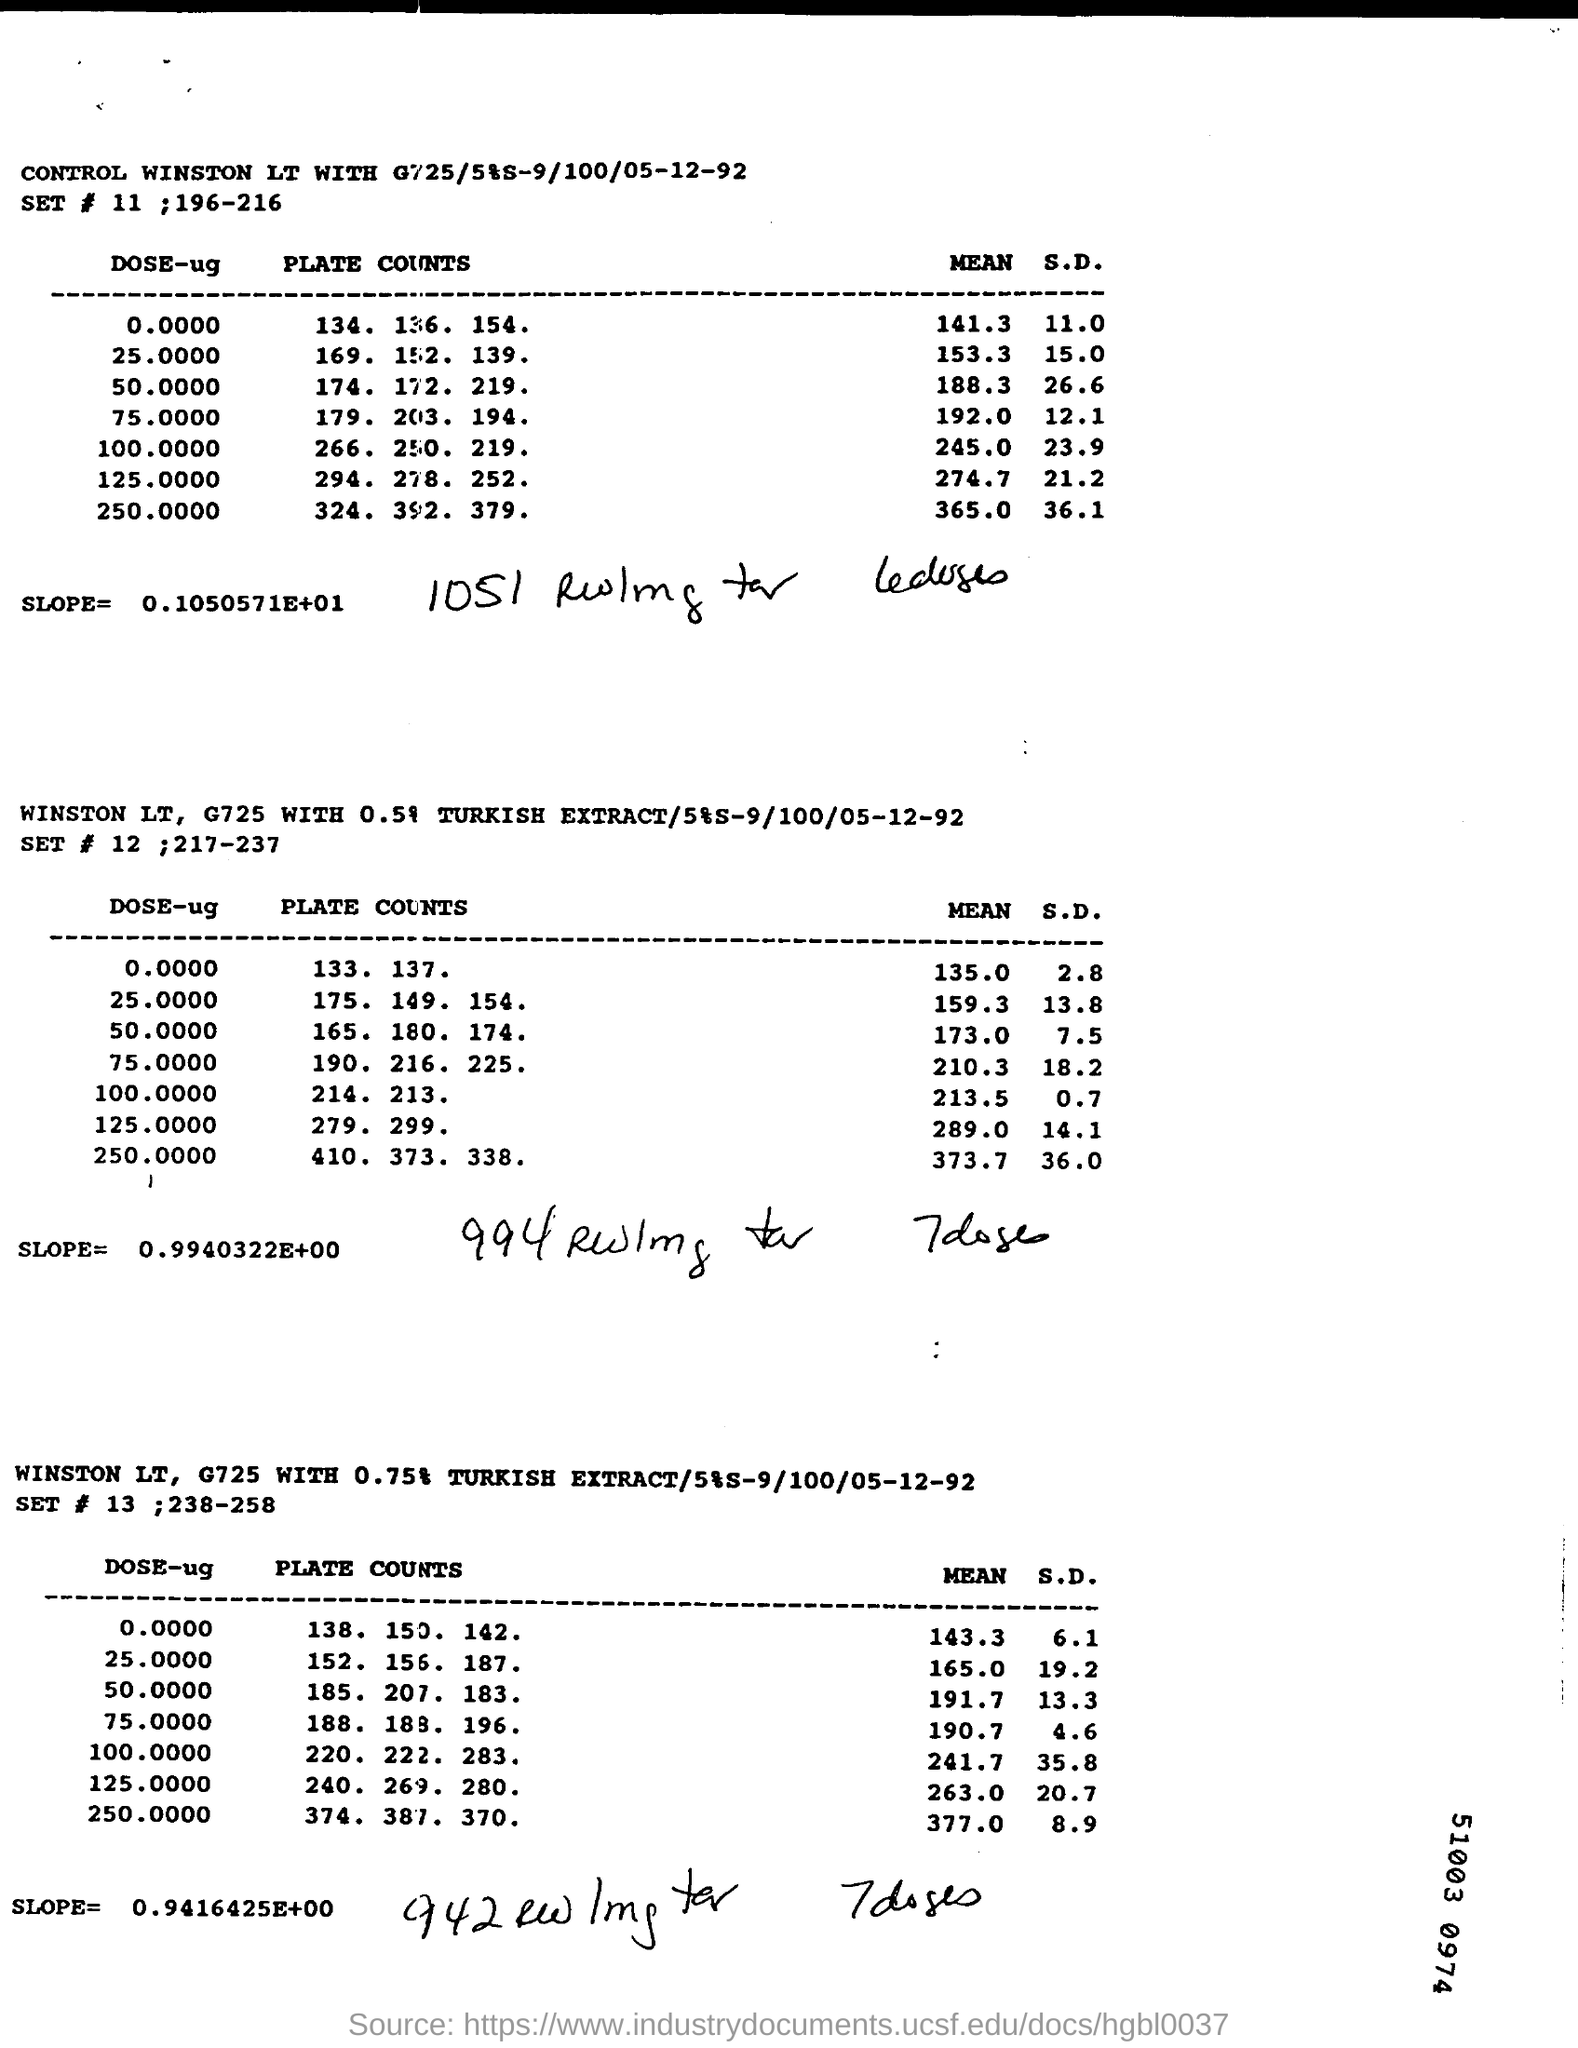Mention a couple of crucial points in this snapshot. The mean of the first value of DOSE-ug in the table "SET # 11; 196-216" is 141.3. The slope written under the first table labeled "SET #11;196-216" is 0.1050571 x 10^1, which can be interpreted as a rate of change of 0.1050571 units per one unit increase in the dependent variable. 